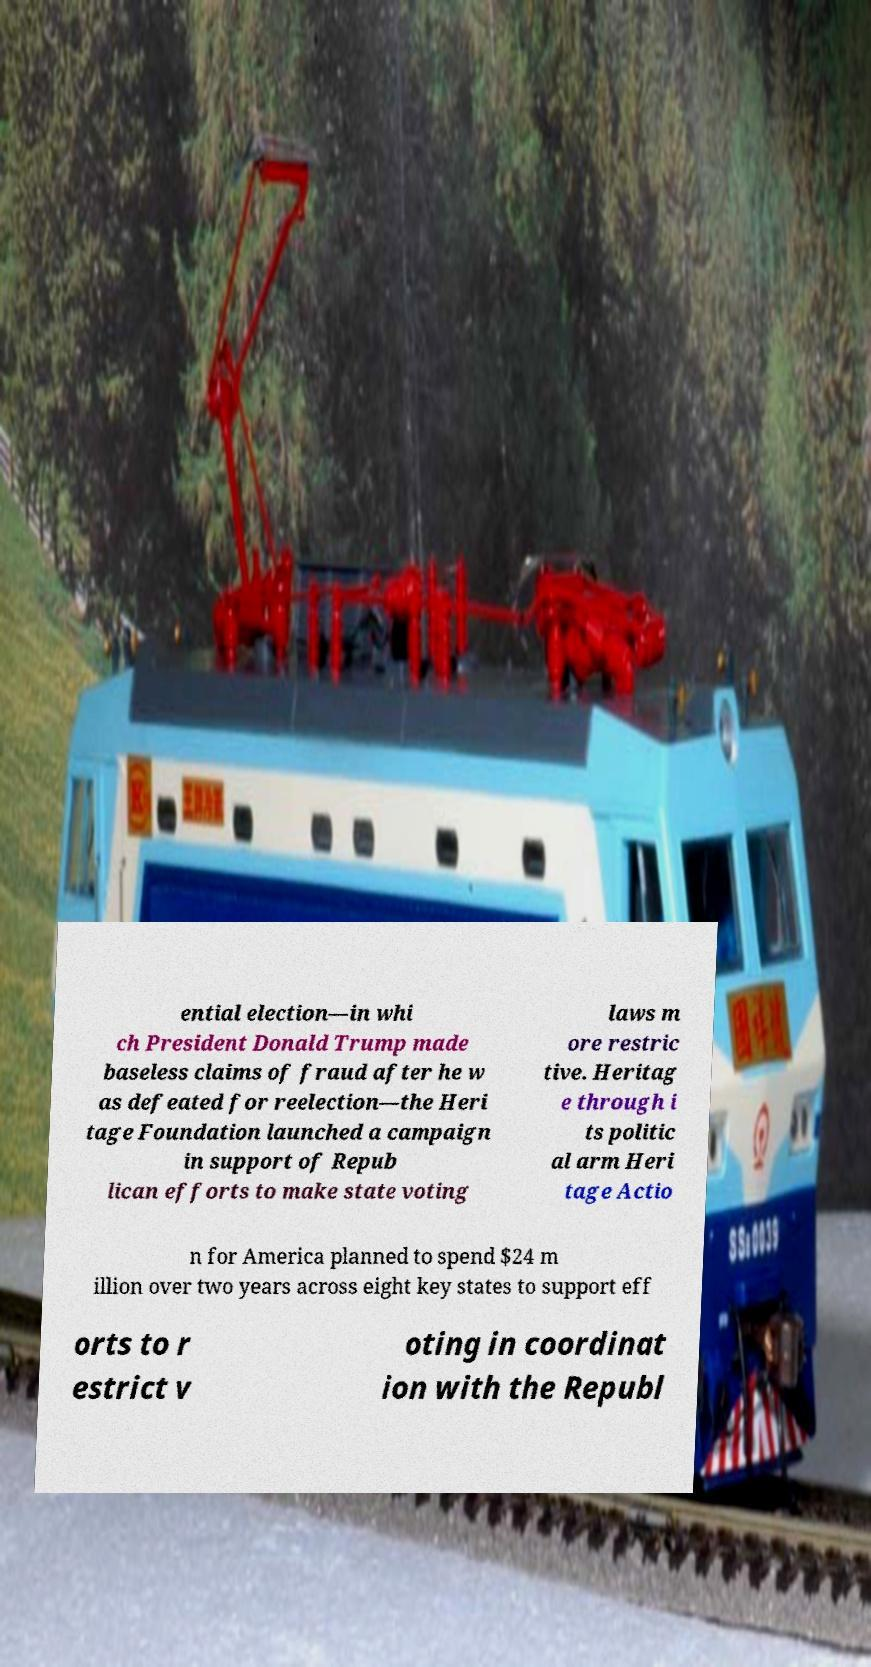Could you extract and type out the text from this image? ential election—in whi ch President Donald Trump made baseless claims of fraud after he w as defeated for reelection—the Heri tage Foundation launched a campaign in support of Repub lican efforts to make state voting laws m ore restric tive. Heritag e through i ts politic al arm Heri tage Actio n for America planned to spend $24 m illion over two years across eight key states to support eff orts to r estrict v oting in coordinat ion with the Republ 